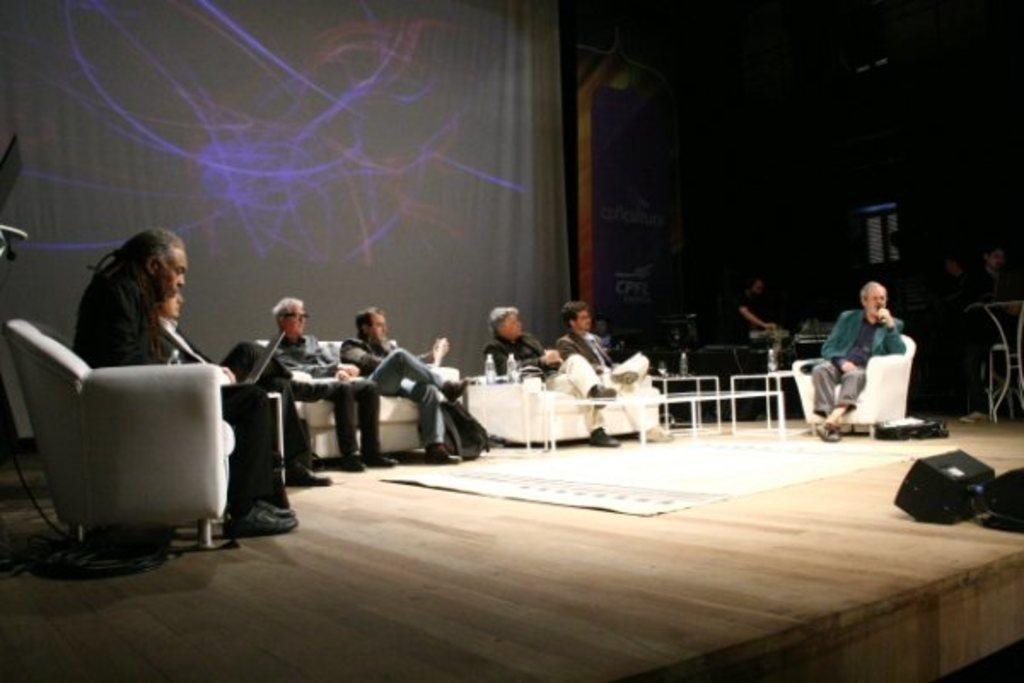Could you give a brief overview of what you see in this image? Here we can see a group of people sitting on chairs and the person on the right side is speaking something in the microphone present in his hand and the person on the left side is operating his laptop and there is a table in front of them 